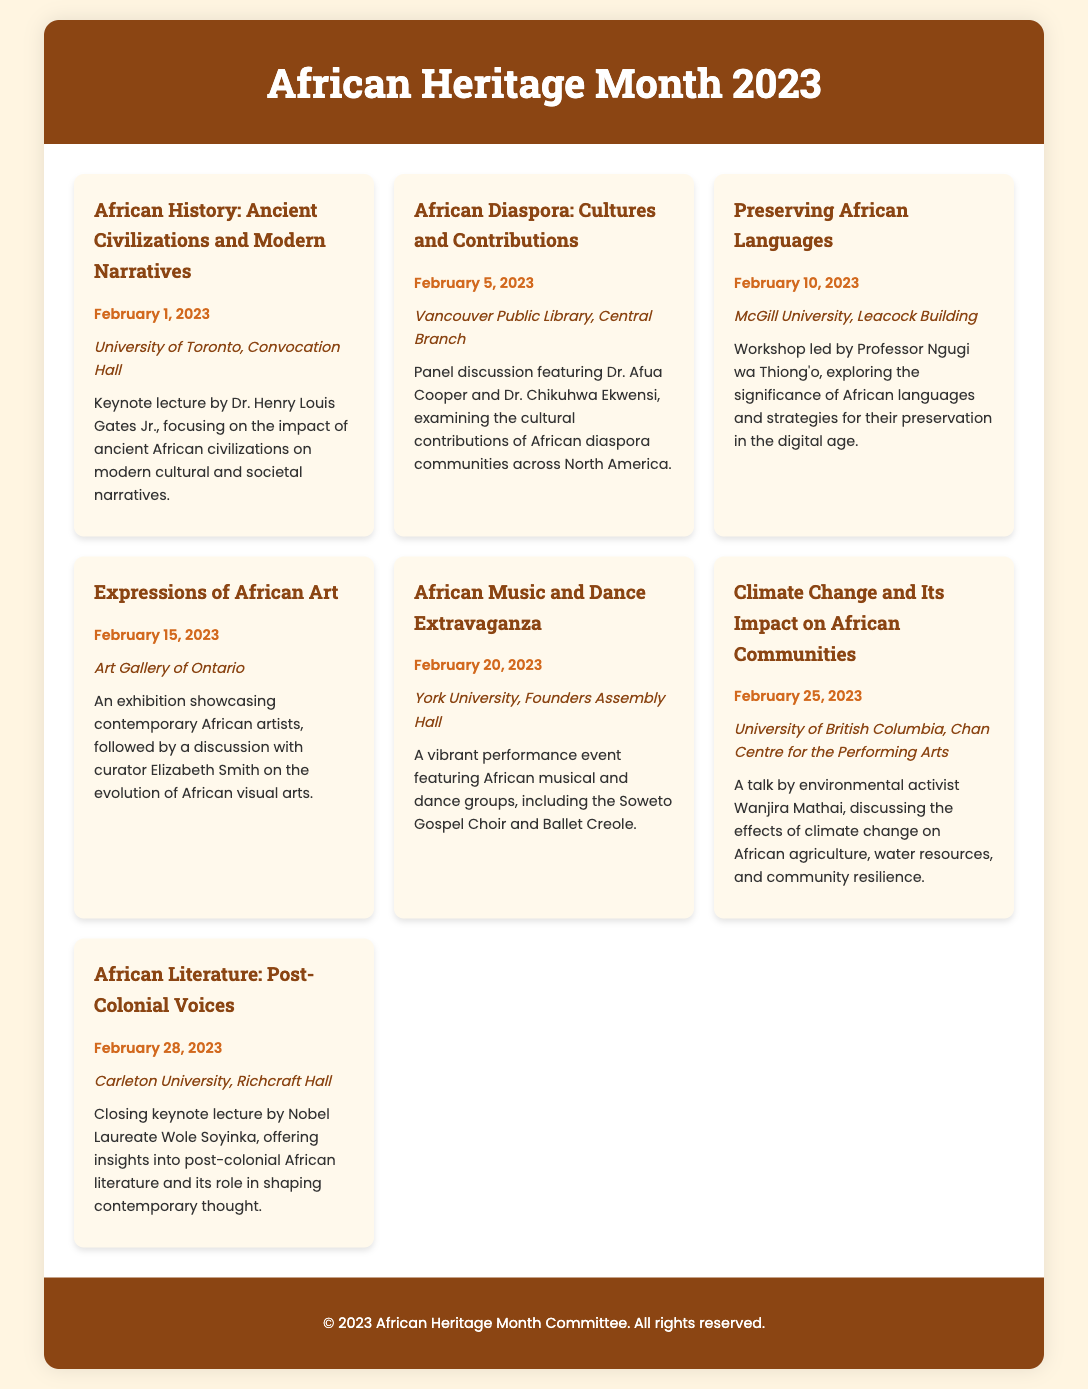What is the title of the keynote lecture on February 1, 2023? The title of the keynote lecture is stated in the document and is "African History: Ancient Civilizations and Modern Narratives."
Answer: African History: Ancient Civilizations and Modern Narratives Who is leading the workshop on preserving African languages? The person leading the workshop is mentioned in the document as Professor Ngugi wa Thiong'o.
Answer: Professor Ngugi wa Thiong'o What is the date of the African Music and Dance Extravaganza? The date can be easily found in the document as February 20, 2023.
Answer: February 20, 2023 Which location hosts the closing keynote lecture? The document specifies that it takes place at Carleton University, Richcraft Hall.
Answer: Carleton University, Richcraft Hall Who will be discussing climate change and its impact on African communities? The speaker is identified in the document as environmental activist Wanjira Mathai.
Answer: Wanjira Mathai What type of event is scheduled for February 15, 2023? The document describes an exhibition focusing on contemporary African artists and includes a discussion.
Answer: Exhibition How many events are listed in total for African Heritage Month 2023? The total number of events can be counted from the document, which states there are seven events.
Answer: Seven What is the main focus of the panel discussion on February 5, 2023? The focus of the panel discussion is articulated in the document, addressing cultural contributions of the African diaspora.
Answer: Cultural contributions of the African diaspora What is the color used for the header in the document? The document indicates that the header background color is #8B4513.
Answer: #8B4513 